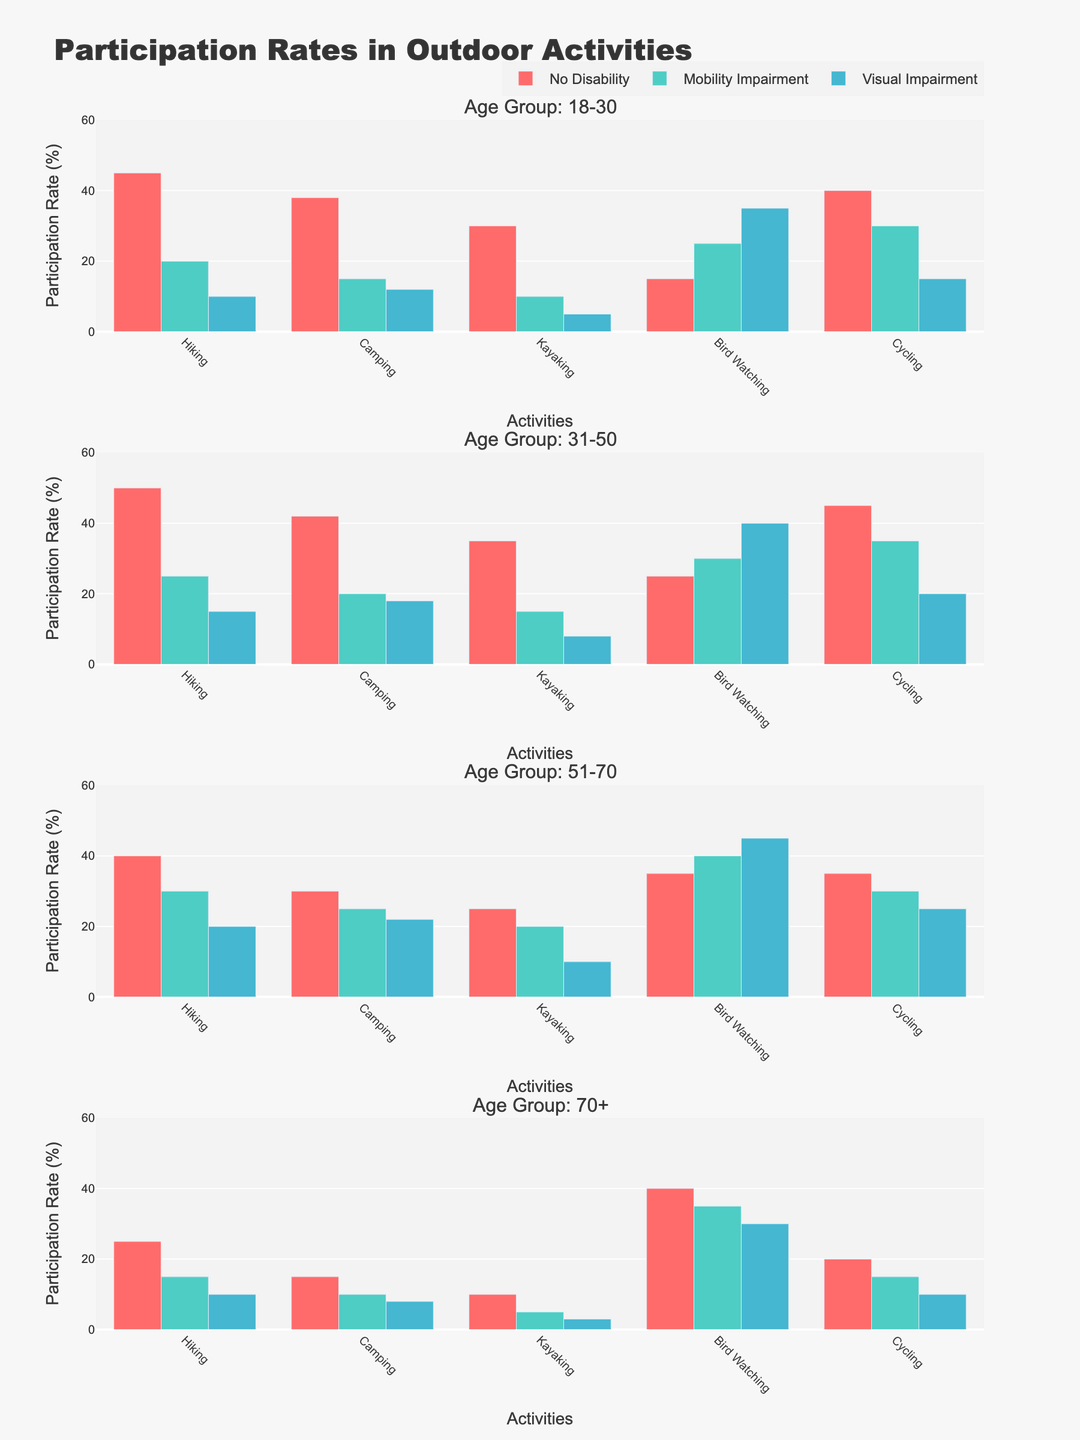How many age groups are represented in the figure? There are four subplot titles, each specifying a unique age group: "18-30", "31-50", "51-70", and "70+".
Answer: 4 Which activity has the highest participation rate for the age group 31-50 with no disability? In the subplot for the age group 31-50, the bar representing individuals with no disability is highest for Hiking at 50%.
Answer: Hiking What is the difference in participation rates for Hiking between age group 18-30 with a mobility impairment and age group 70+ with a mobility impairment? For the 18-30 age group with a mobility impairment, the Hiking participation rate is 20%. For the 70+ age group with a mobility impairment, it is 15%. The difference is 20% - 15% = 5%.
Answer: 5% Which ability level group has the lowest participation rate for Bird Watching in the age group 51-70? In the subplot for the age group 51-70, the Visual Impairment group has the lowest bar for Bird Watching at 45%, compared to others.
Answer: No Disability Is the participation rate for Camping higher in the age group 31-50 with a mobility impairment or in the age group 51-70 with a visual impairment? In the subplot for the age group 31-50, the bar for Camping with a mobility impairment is 20%. In the 51-70 age group, the bar for Camping with a visual impairment is 22%.
Answer: Age group 51-70 with visual impairment What is the average participation rate for Kayaking across all age groups for individuals with no disability? To find the average, add the participation rates for Kayaking in the No Disability group across all age groups: 30% (18-30) + 35% (31-50) + 25% (51-70) + 10% (70+). Sum = 30 + 35 + 25 + 10 = 100. Average = 100 / 4 = 25%.
Answer: 25% Which age group has the highest participation rate for Cycling regardless of ability level? The highest participation rate for Cycling across all age groups is found by looking at the tallest bar for Cycling in each subplot. The highest rate is 45% in age group 31-50 with no disability.
Answer: 31-50 Is there any age group where Visual Impairment has a higher participation rate in Bird Watching than No Disability? In the subplot for the age group 51-70, the Visual Impairment group shows a higher participation rate (45%) in Bird Watching compared to No Disability (35%).
Answer: Yes 